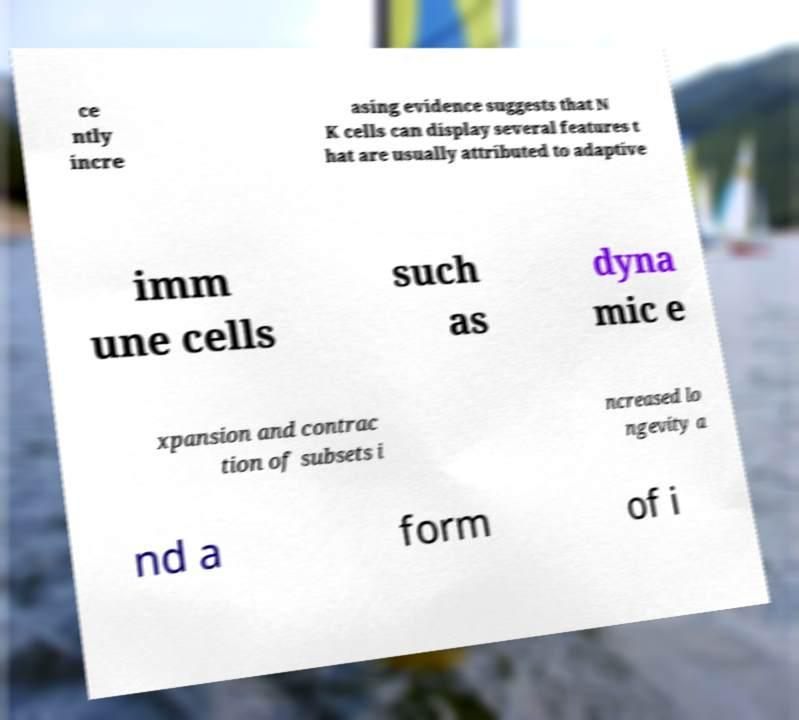Please identify and transcribe the text found in this image. ce ntly incre asing evidence suggests that N K cells can display several features t hat are usually attributed to adaptive imm une cells such as dyna mic e xpansion and contrac tion of subsets i ncreased lo ngevity a nd a form of i 